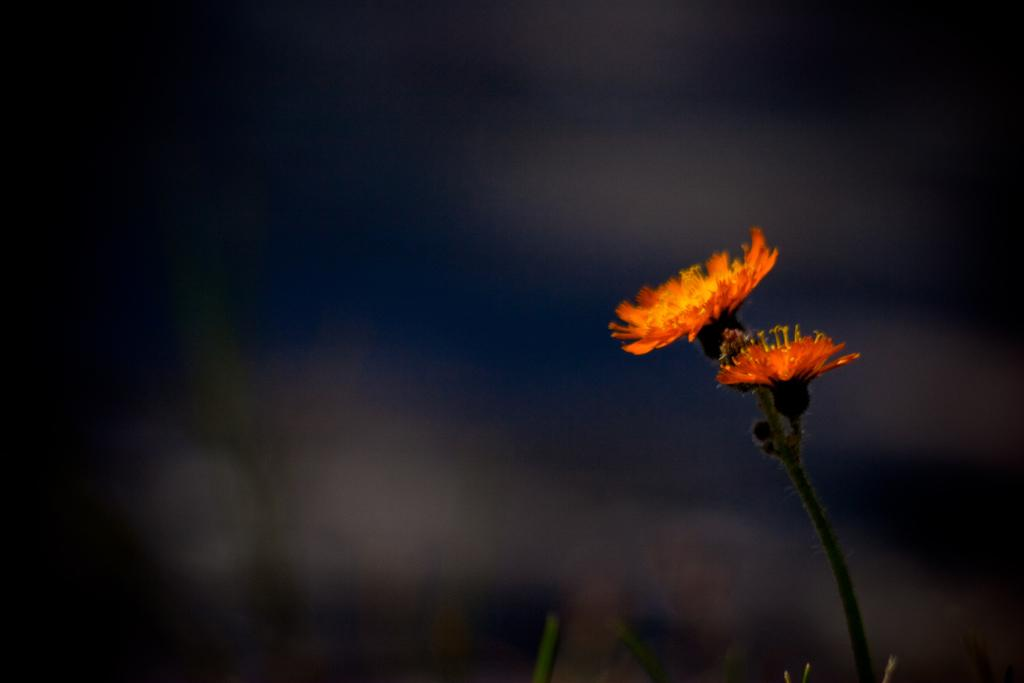What type of plant is in the image? There is a sunflower in the image. Where is the sunflower located in the image? The sunflower is located at the right side of the image. What hobbies does the sunflower enjoy in the image? Sunflowers do not have hobbies, as they are plants and not sentient beings. 